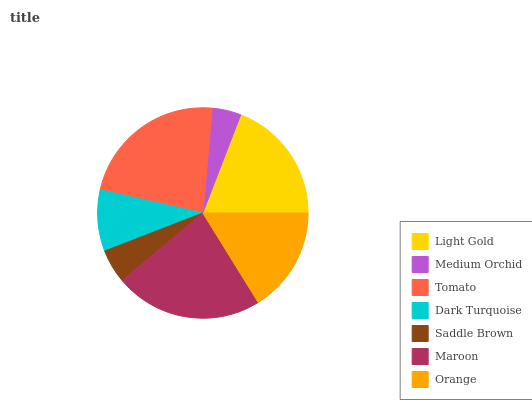Is Medium Orchid the minimum?
Answer yes or no. Yes. Is Tomato the maximum?
Answer yes or no. Yes. Is Tomato the minimum?
Answer yes or no. No. Is Medium Orchid the maximum?
Answer yes or no. No. Is Tomato greater than Medium Orchid?
Answer yes or no. Yes. Is Medium Orchid less than Tomato?
Answer yes or no. Yes. Is Medium Orchid greater than Tomato?
Answer yes or no. No. Is Tomato less than Medium Orchid?
Answer yes or no. No. Is Orange the high median?
Answer yes or no. Yes. Is Orange the low median?
Answer yes or no. Yes. Is Maroon the high median?
Answer yes or no. No. Is Tomato the low median?
Answer yes or no. No. 